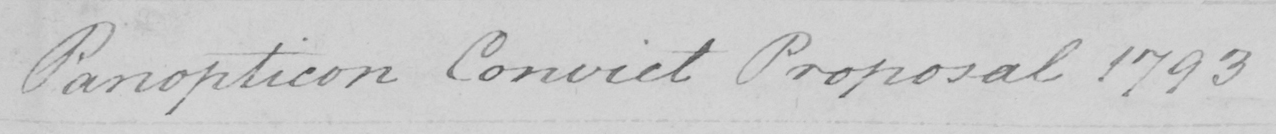What text is written in this handwritten line? Panopticon Convict Proposal 1793 